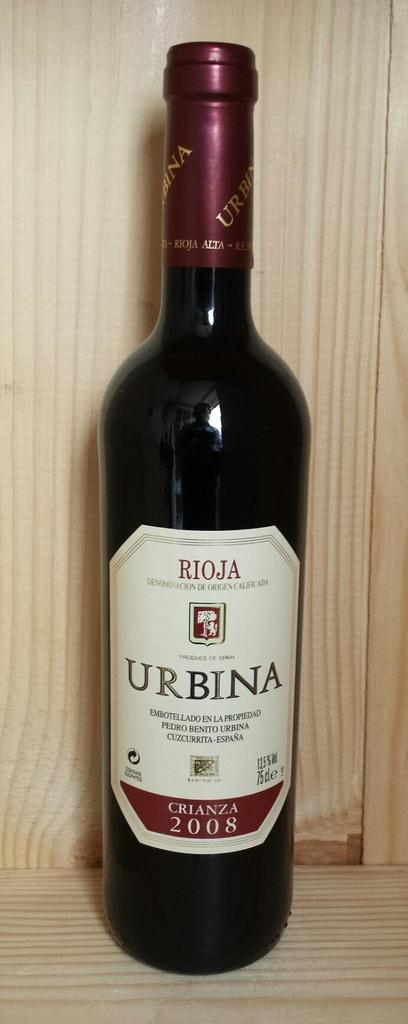<image>
Relay a brief, clear account of the picture shown. The bottle of Rioja was made in 2008. 